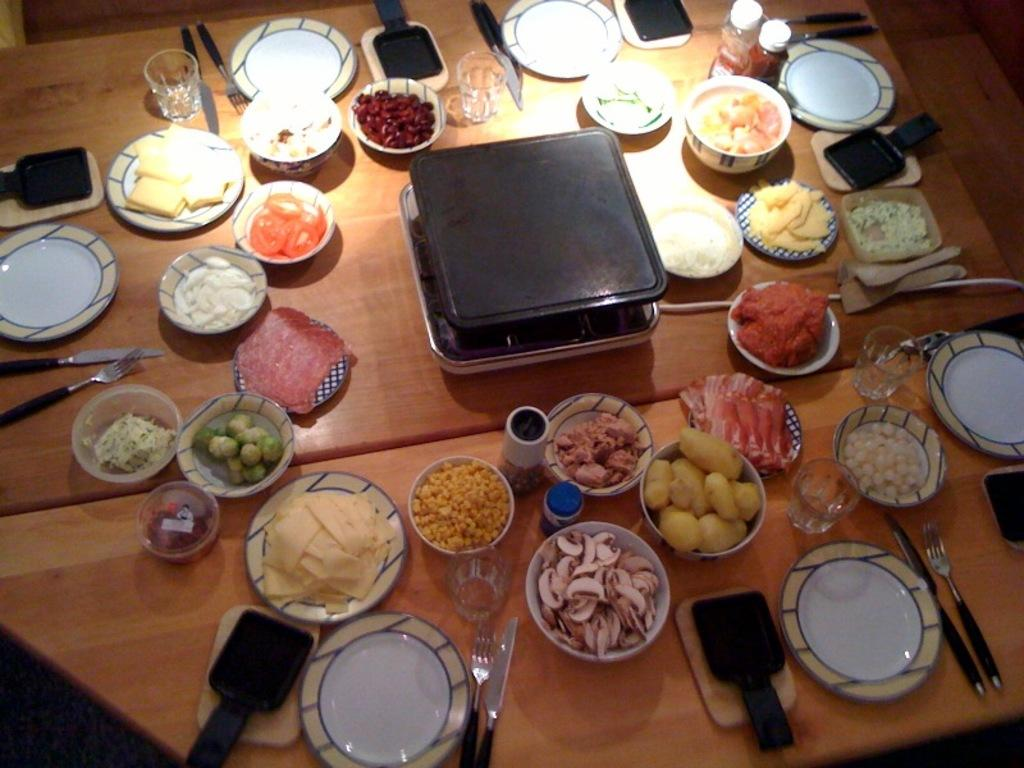What type of food items can be seen in the image? There are food items in bowls and on plates in the image. What type of tableware is present in the image? There are glasses, forks, knives, and serving spoons in the image. What type of accessory is present to protect the table from moisture? There are coasters in the image. What other items can be seen on the table in the image? There are other items on the table in the image, but their specific nature is not mentioned in the provided facts. How many windows are visible in the image? There is no information about windows in the provided facts, so it cannot be determined from the image. What type of corn is being served on the plates in the image? There is no corn present in the image, so it cannot be determined from the image. 